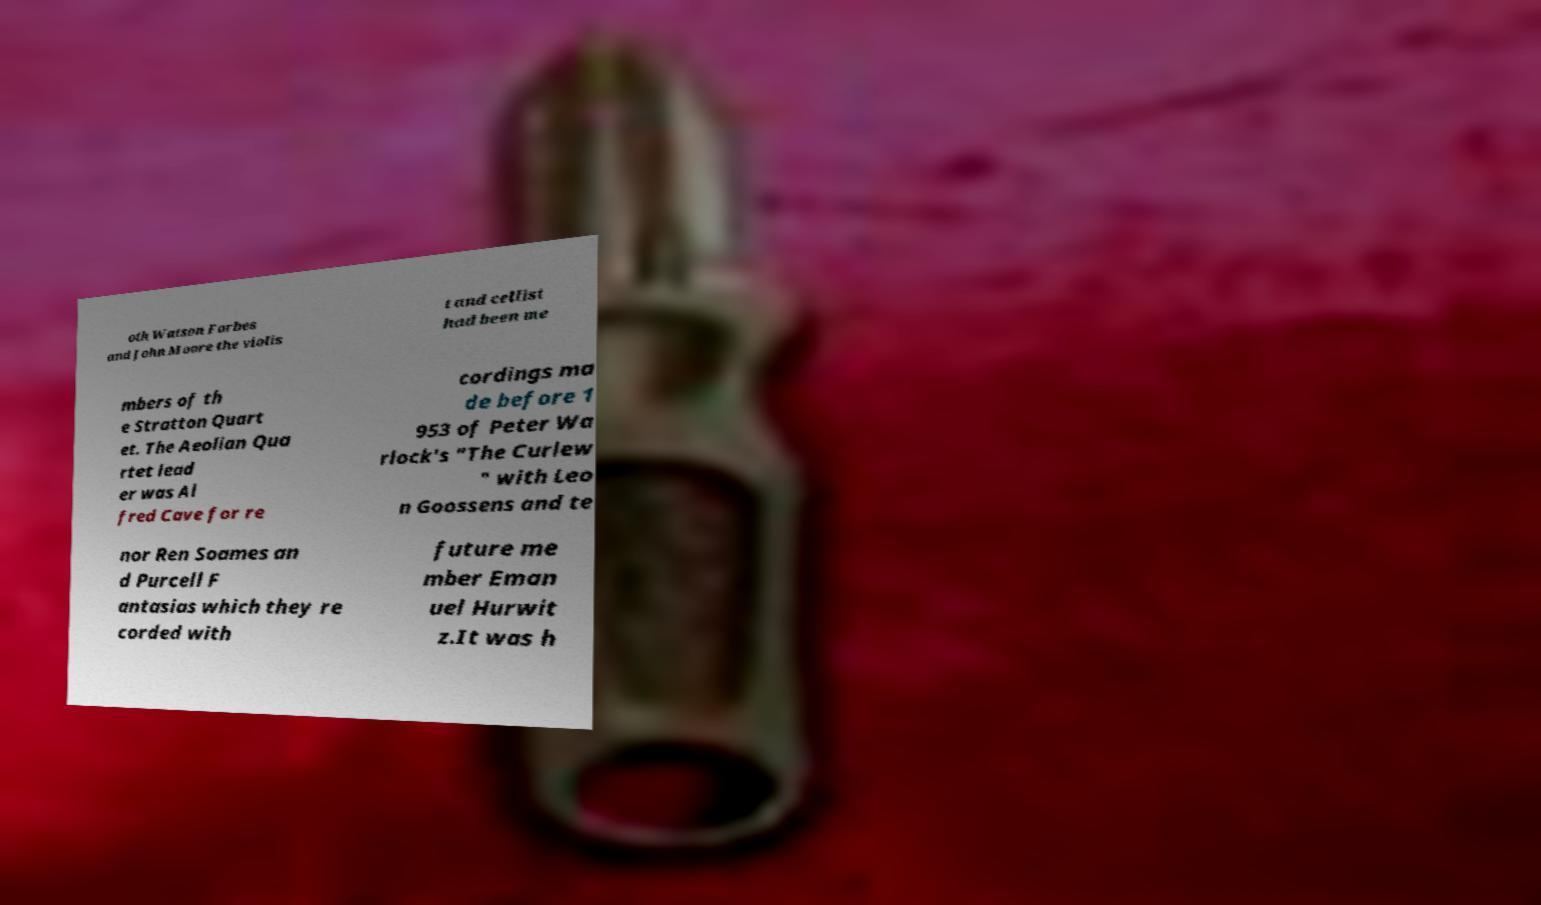Please read and relay the text visible in this image. What does it say? oth Watson Forbes and John Moore the violis t and cellist had been me mbers of th e Stratton Quart et. The Aeolian Qua rtet lead er was Al fred Cave for re cordings ma de before 1 953 of Peter Wa rlock's "The Curlew " with Leo n Goossens and te nor Ren Soames an d Purcell F antasias which they re corded with future me mber Eman uel Hurwit z.It was h 